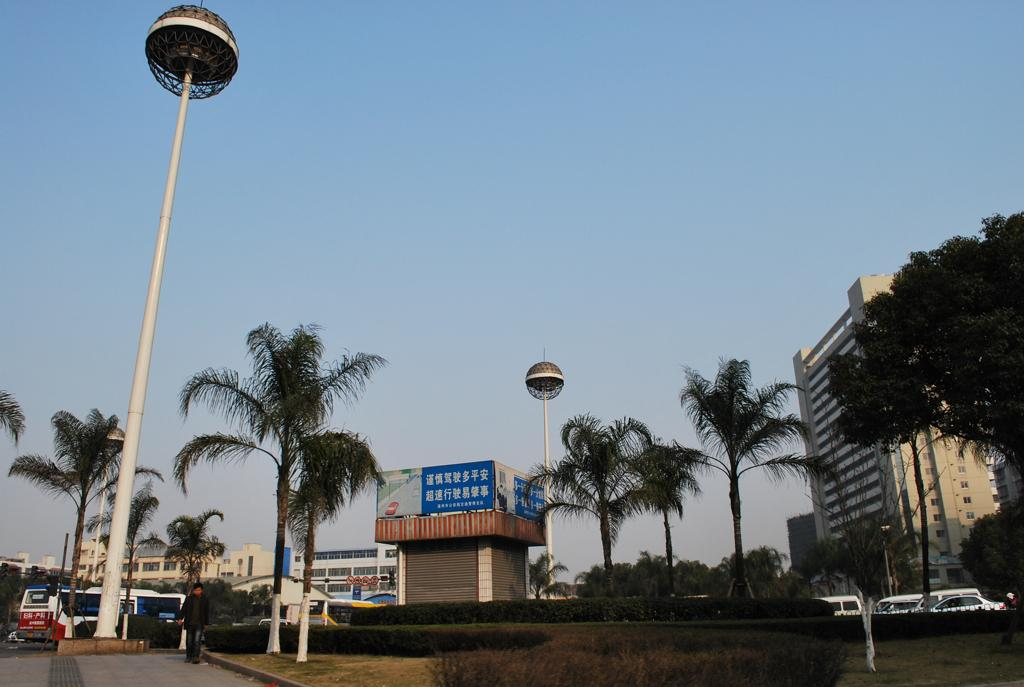What is the person in the image doing? There is a person walking on a footpath in the image. What type of vegetation can be seen in the image? Trees are present in the image. What type of structures are visible in the image? Buildings are visible in the image. What type of window covering is present in the image? Shutters are present in the image. What type of decoration or advertisement is visible in the image? Banners are visible in the image. What type of transportation is present in the image? Vehicles are present in the image. What type of vertical support is visible in the image? Poles are visible in the image. What type of living organisms are present in the image besides the person? Plants are present in the image. What is visible in the background of the image? The sky is visible in the background of the image. Can you see a kite flying in the image? There is no kite visible in the image. How does the person in the image join the other people in the image? The person in the image is already walking, so there is no need for them to join others. 